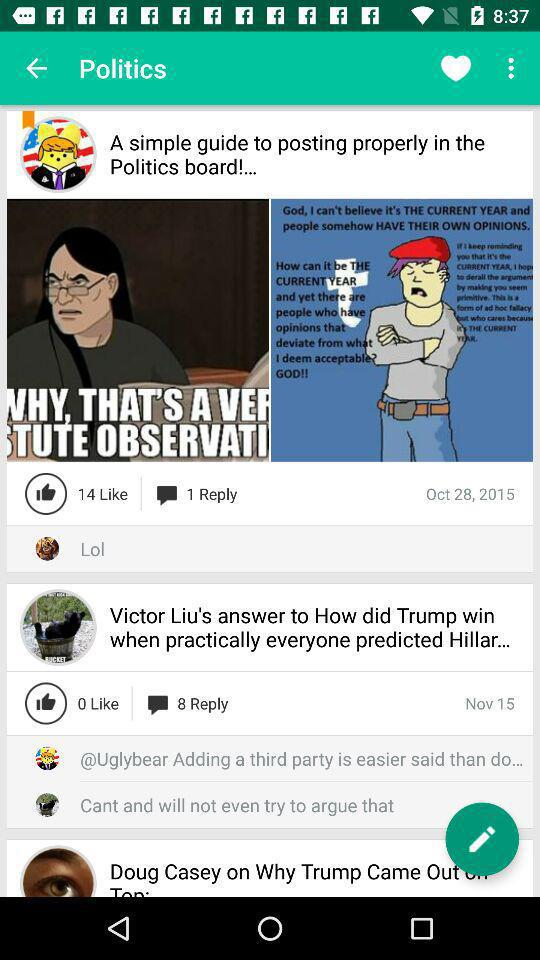What is the posted date of Victor Liu's post? The posted date of Victor Liu's post is November 15. 